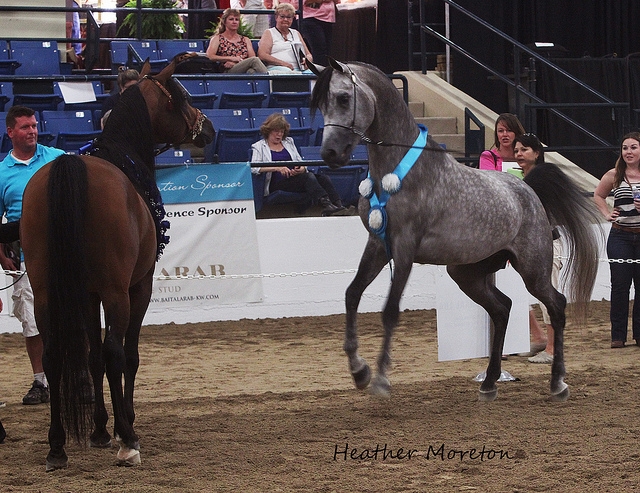Identify the text contained in this image. Tian pence Sponsor Heather Moreton 